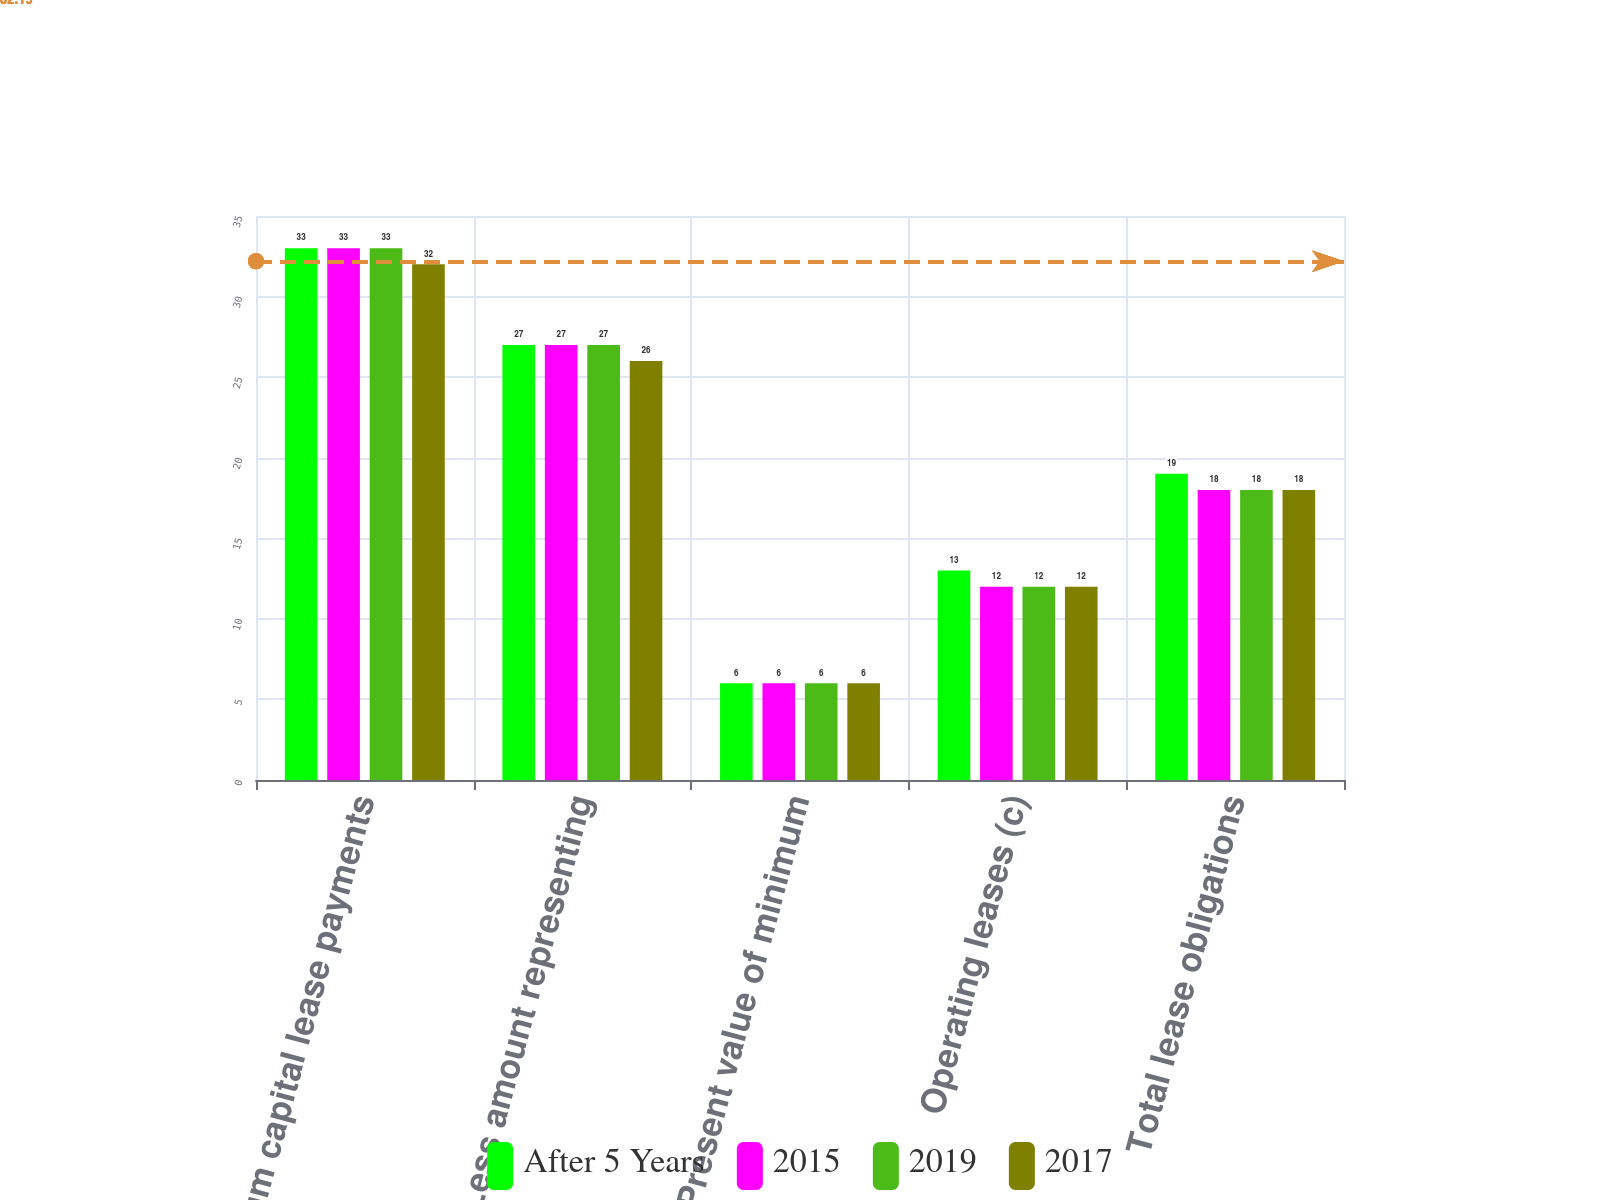<chart> <loc_0><loc_0><loc_500><loc_500><stacked_bar_chart><ecel><fcel>Minimum capital lease payments<fcel>Less amount representing<fcel>Present value of minimum<fcel>Operating leases (c)<fcel>Total lease obligations<nl><fcel>After 5 Years<fcel>33<fcel>27<fcel>6<fcel>13<fcel>19<nl><fcel>2015<fcel>33<fcel>27<fcel>6<fcel>12<fcel>18<nl><fcel>2019<fcel>33<fcel>27<fcel>6<fcel>12<fcel>18<nl><fcel>2017<fcel>32<fcel>26<fcel>6<fcel>12<fcel>18<nl></chart> 